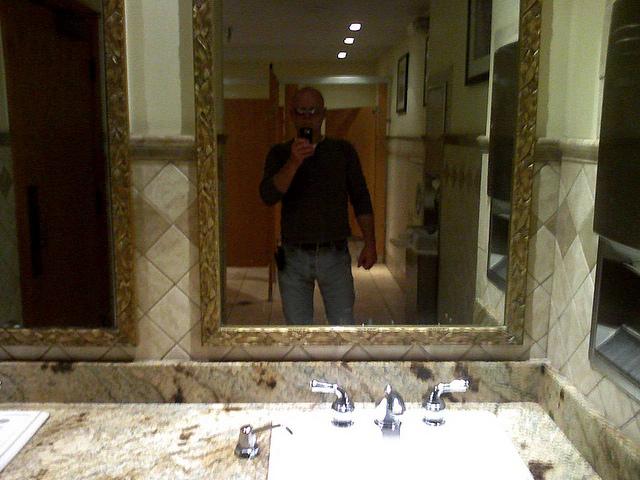Where was this taken?
Keep it brief. Bathroom. How many heads are there?
Write a very short answer. 1. Is there another sink?
Be succinct. Yes. What is the gender of the person reflected in the mirror?
Write a very short answer. Male. 